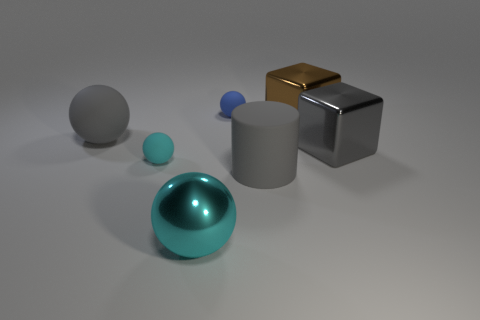Subtract 1 balls. How many balls are left? 3 Add 2 tiny blue objects. How many objects exist? 9 Subtract all cylinders. How many objects are left? 6 Add 1 blocks. How many blocks exist? 3 Subtract 0 green blocks. How many objects are left? 7 Subtract all rubber spheres. Subtract all large gray balls. How many objects are left? 3 Add 4 tiny things. How many tiny things are left? 6 